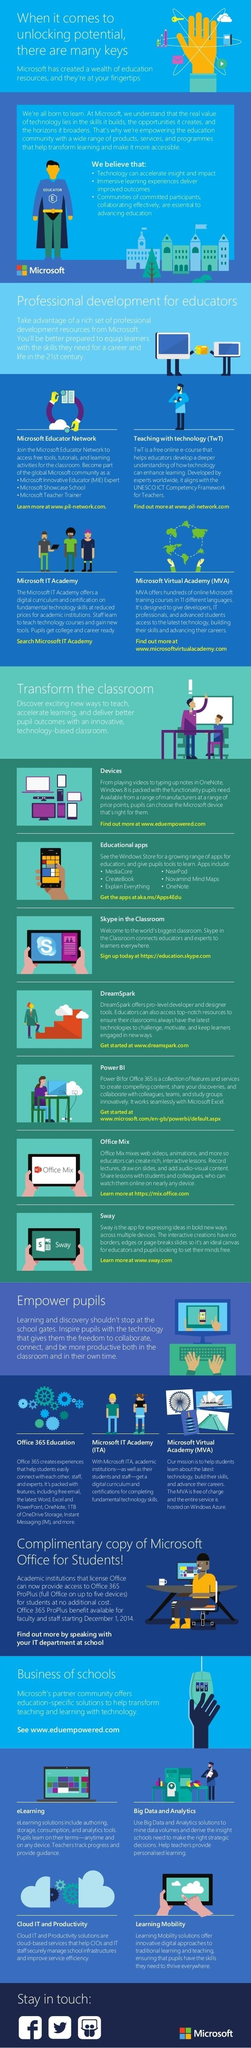Mention a couple of crucial points in this snapshot. The tablet screen displays three technology tools used for education: Skype in the Classroom, Office Mix, and Sway. Microsoft Virtual Academy is an initiative that helps students upgrade their skills free of cost, which is part of the Microsoft Educator Network and Microsoft IT Academy. 